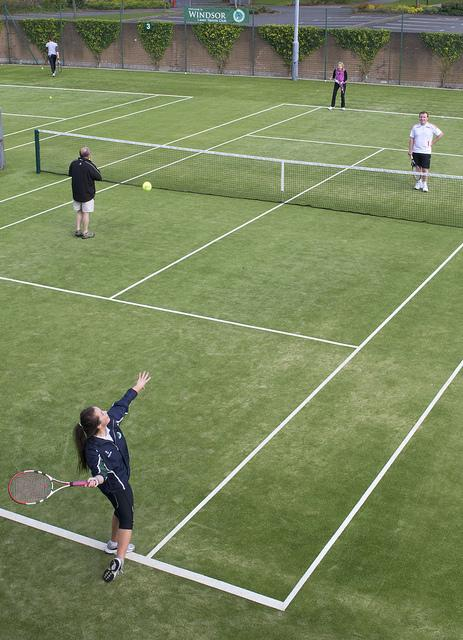What is the minimum number of players who can partake in a match of this sport? two 